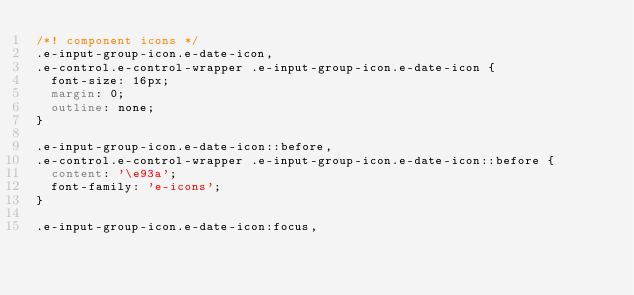Convert code to text. <code><loc_0><loc_0><loc_500><loc_500><_CSS_>/*! component icons */
.e-input-group-icon.e-date-icon,
.e-control.e-control-wrapper .e-input-group-icon.e-date-icon {
  font-size: 16px;
  margin: 0;
  outline: none;
}

.e-input-group-icon.e-date-icon::before,
.e-control.e-control-wrapper .e-input-group-icon.e-date-icon::before {
  content: '\e93a';
  font-family: 'e-icons';
}

.e-input-group-icon.e-date-icon:focus,</code> 